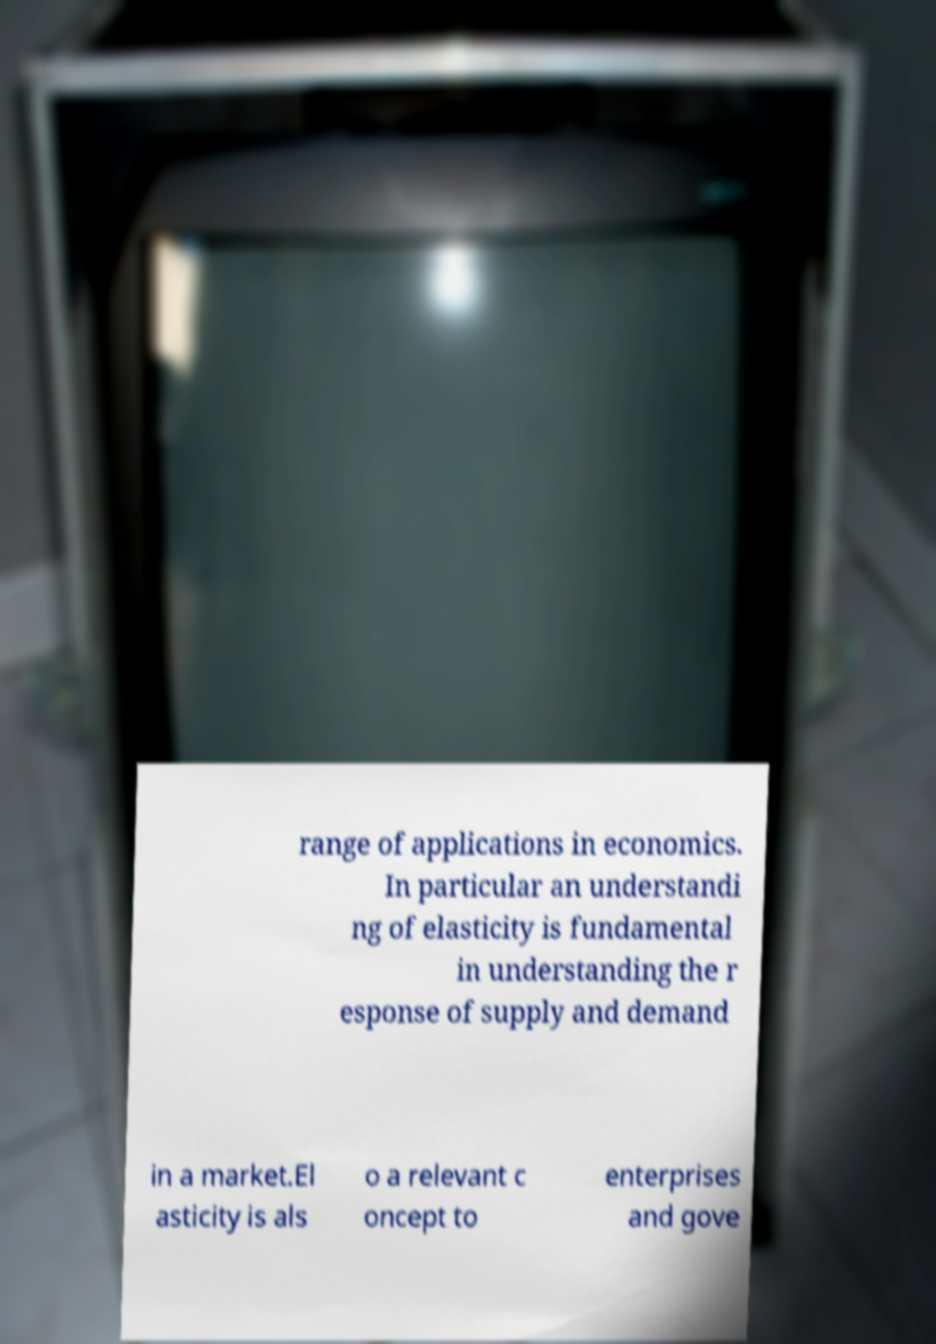I need the written content from this picture converted into text. Can you do that? range of applications in economics. In particular an understandi ng of elasticity is fundamental in understanding the r esponse of supply and demand in a market.El asticity is als o a relevant c oncept to enterprises and gove 